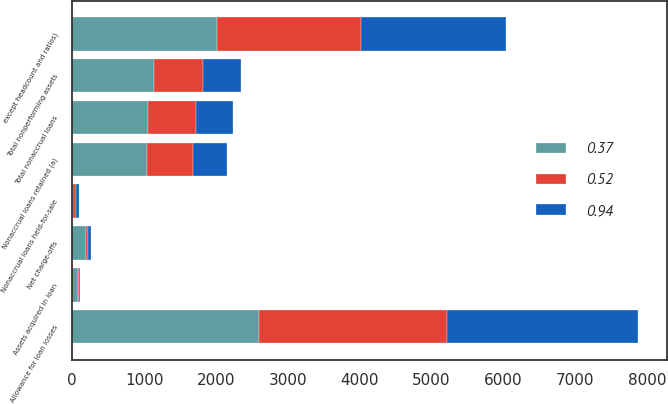Convert chart. <chart><loc_0><loc_0><loc_500><loc_500><stacked_bar_chart><ecel><fcel>except headcount and ratios)<fcel>Net charge-offs<fcel>Nonaccrual loans retained (a)<fcel>Nonaccrual loans held-for-sale<fcel>Total nonaccrual loans<fcel>Assets acquired in loan<fcel>Total nonperforming assets<fcel>Allowance for loan losses<nl><fcel>0.94<fcel>2013<fcel>43<fcel>471<fcel>43<fcel>514<fcel>15<fcel>529<fcel>2669<nl><fcel>0.52<fcel>2012<fcel>35<fcel>644<fcel>29<fcel>673<fcel>14<fcel>687<fcel>2610<nl><fcel>0.37<fcel>2011<fcel>187<fcel>1036<fcel>17<fcel>1053<fcel>85<fcel>1138<fcel>2603<nl></chart> 